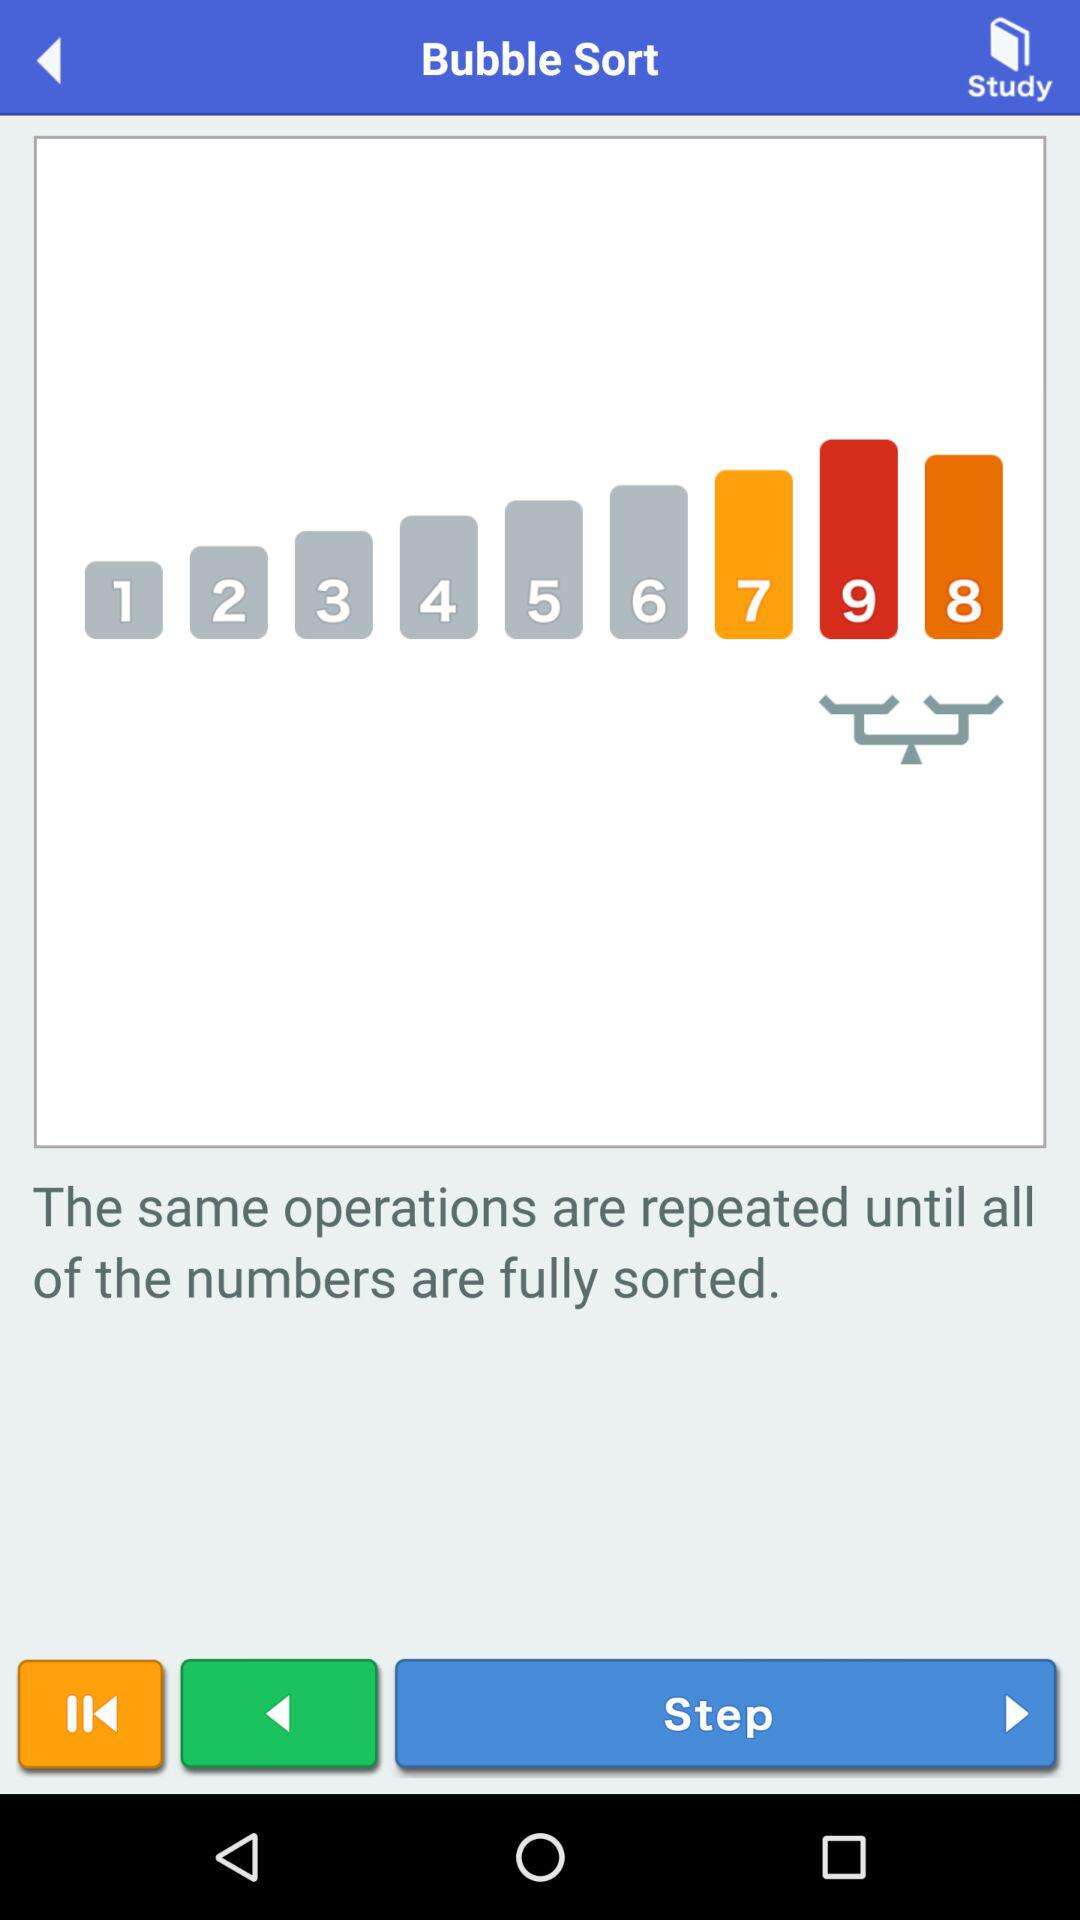How many numbers are greater than 5?
Answer the question using a single word or phrase. 4 